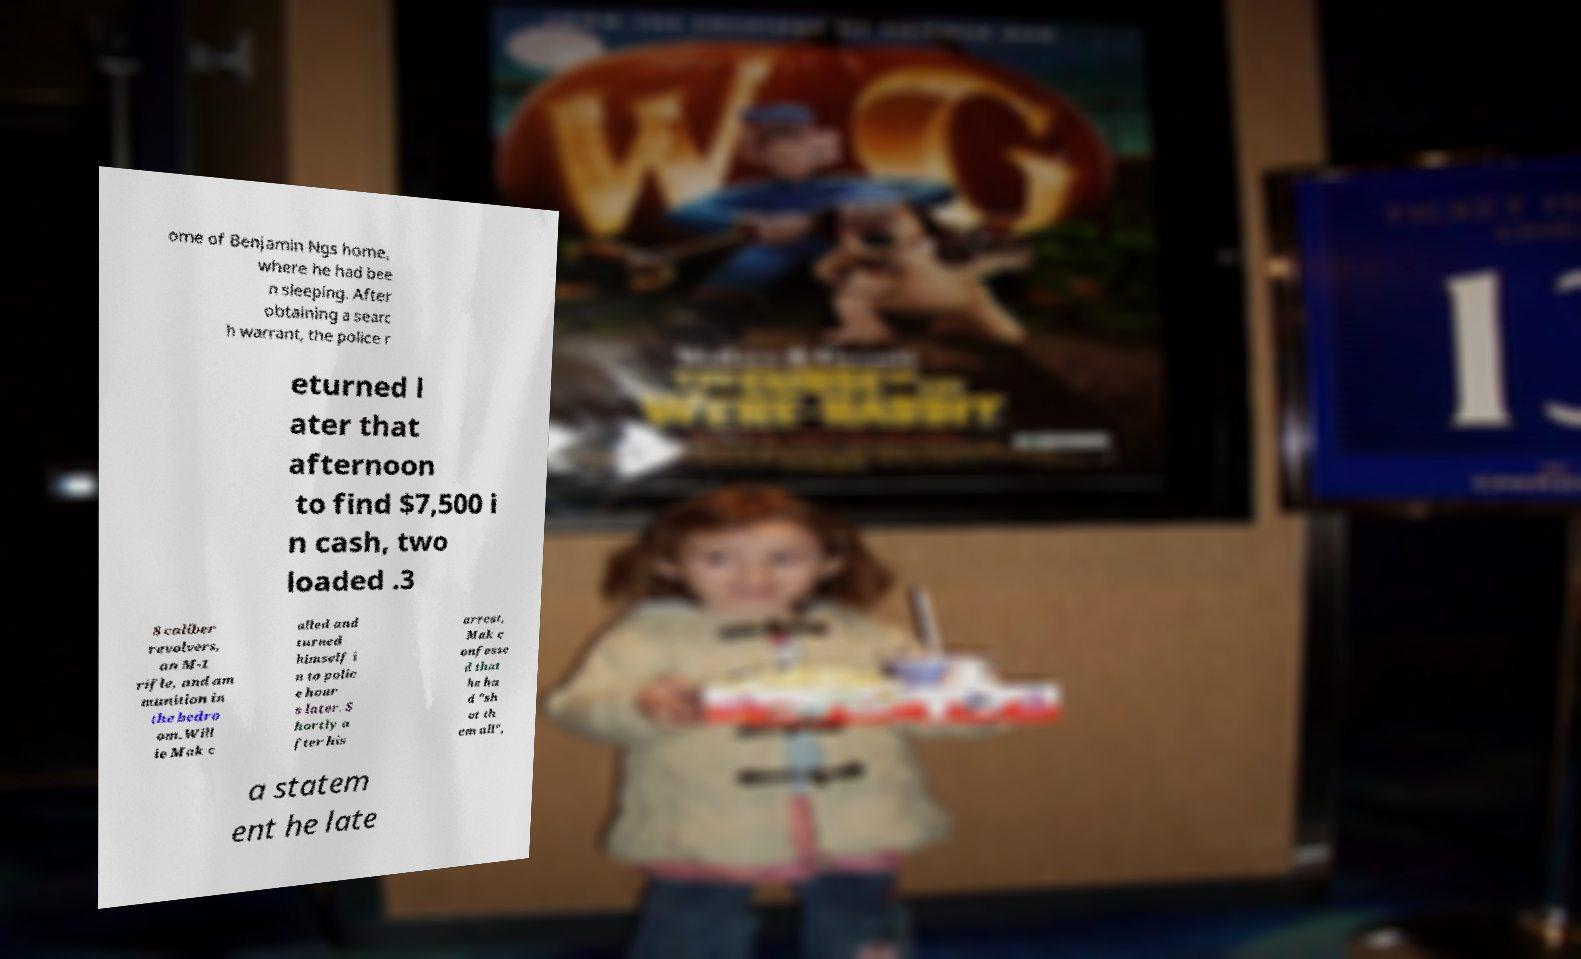For documentation purposes, I need the text within this image transcribed. Could you provide that? ome of Benjamin Ngs home, where he had bee n sleeping. After obtaining a searc h warrant, the police r eturned l ater that afternoon to find $7,500 i n cash, two loaded .3 8 caliber revolvers, an M-1 rifle, and am munition in the bedro om.Will ie Mak c alled and turned himself i n to polic e hour s later. S hortly a fter his arrest, Mak c onfesse d that he ha d "sh ot th em all", a statem ent he late 